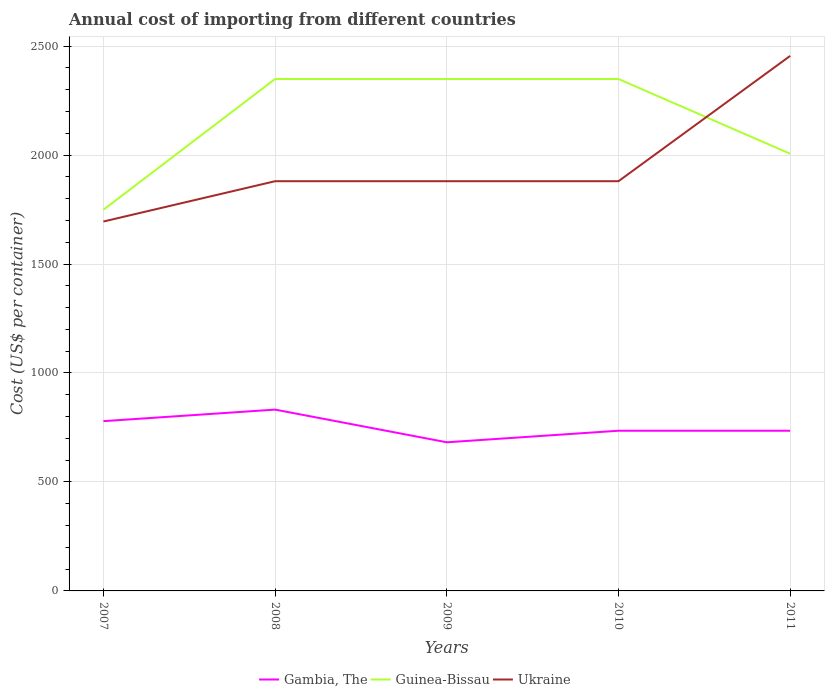How many different coloured lines are there?
Your answer should be very brief. 3. Is the number of lines equal to the number of legend labels?
Offer a very short reply. Yes. Across all years, what is the maximum total annual cost of importing in Ukraine?
Keep it short and to the point. 1695. In which year was the total annual cost of importing in Gambia, The maximum?
Ensure brevity in your answer.  2009. What is the total total annual cost of importing in Gambia, The in the graph?
Make the answer very short. 97. What is the difference between the highest and the second highest total annual cost of importing in Ukraine?
Your answer should be very brief. 760. What is the difference between the highest and the lowest total annual cost of importing in Guinea-Bissau?
Provide a short and direct response. 3. What is the difference between two consecutive major ticks on the Y-axis?
Ensure brevity in your answer.  500. Does the graph contain any zero values?
Your response must be concise. No. Does the graph contain grids?
Keep it short and to the point. Yes. How are the legend labels stacked?
Give a very brief answer. Horizontal. What is the title of the graph?
Provide a short and direct response. Annual cost of importing from different countries. Does "New Caledonia" appear as one of the legend labels in the graph?
Your answer should be very brief. No. What is the label or title of the X-axis?
Offer a terse response. Years. What is the label or title of the Y-axis?
Offer a terse response. Cost (US$ per container). What is the Cost (US$ per container) in Gambia, The in 2007?
Provide a short and direct response. 779. What is the Cost (US$ per container) in Guinea-Bissau in 2007?
Your answer should be very brief. 1749. What is the Cost (US$ per container) of Ukraine in 2007?
Offer a very short reply. 1695. What is the Cost (US$ per container) of Gambia, The in 2008?
Offer a very short reply. 832. What is the Cost (US$ per container) of Guinea-Bissau in 2008?
Make the answer very short. 2349. What is the Cost (US$ per container) in Ukraine in 2008?
Give a very brief answer. 1880. What is the Cost (US$ per container) of Gambia, The in 2009?
Your answer should be very brief. 682. What is the Cost (US$ per container) in Guinea-Bissau in 2009?
Offer a terse response. 2349. What is the Cost (US$ per container) of Ukraine in 2009?
Your answer should be very brief. 1880. What is the Cost (US$ per container) of Gambia, The in 2010?
Your answer should be compact. 735. What is the Cost (US$ per container) in Guinea-Bissau in 2010?
Ensure brevity in your answer.  2349. What is the Cost (US$ per container) in Ukraine in 2010?
Offer a terse response. 1880. What is the Cost (US$ per container) of Gambia, The in 2011?
Ensure brevity in your answer.  735. What is the Cost (US$ per container) in Guinea-Bissau in 2011?
Provide a succinct answer. 2006. What is the Cost (US$ per container) in Ukraine in 2011?
Your answer should be very brief. 2455. Across all years, what is the maximum Cost (US$ per container) in Gambia, The?
Provide a succinct answer. 832. Across all years, what is the maximum Cost (US$ per container) in Guinea-Bissau?
Your answer should be compact. 2349. Across all years, what is the maximum Cost (US$ per container) in Ukraine?
Your answer should be compact. 2455. Across all years, what is the minimum Cost (US$ per container) in Gambia, The?
Give a very brief answer. 682. Across all years, what is the minimum Cost (US$ per container) in Guinea-Bissau?
Give a very brief answer. 1749. Across all years, what is the minimum Cost (US$ per container) of Ukraine?
Ensure brevity in your answer.  1695. What is the total Cost (US$ per container) in Gambia, The in the graph?
Offer a terse response. 3763. What is the total Cost (US$ per container) of Guinea-Bissau in the graph?
Ensure brevity in your answer.  1.08e+04. What is the total Cost (US$ per container) of Ukraine in the graph?
Provide a succinct answer. 9790. What is the difference between the Cost (US$ per container) in Gambia, The in 2007 and that in 2008?
Your answer should be very brief. -53. What is the difference between the Cost (US$ per container) in Guinea-Bissau in 2007 and that in 2008?
Provide a short and direct response. -600. What is the difference between the Cost (US$ per container) in Ukraine in 2007 and that in 2008?
Offer a terse response. -185. What is the difference between the Cost (US$ per container) in Gambia, The in 2007 and that in 2009?
Provide a short and direct response. 97. What is the difference between the Cost (US$ per container) of Guinea-Bissau in 2007 and that in 2009?
Your response must be concise. -600. What is the difference between the Cost (US$ per container) in Ukraine in 2007 and that in 2009?
Provide a succinct answer. -185. What is the difference between the Cost (US$ per container) of Guinea-Bissau in 2007 and that in 2010?
Make the answer very short. -600. What is the difference between the Cost (US$ per container) in Ukraine in 2007 and that in 2010?
Provide a short and direct response. -185. What is the difference between the Cost (US$ per container) in Gambia, The in 2007 and that in 2011?
Your answer should be compact. 44. What is the difference between the Cost (US$ per container) in Guinea-Bissau in 2007 and that in 2011?
Ensure brevity in your answer.  -257. What is the difference between the Cost (US$ per container) in Ukraine in 2007 and that in 2011?
Your answer should be compact. -760. What is the difference between the Cost (US$ per container) in Gambia, The in 2008 and that in 2009?
Give a very brief answer. 150. What is the difference between the Cost (US$ per container) of Guinea-Bissau in 2008 and that in 2009?
Provide a short and direct response. 0. What is the difference between the Cost (US$ per container) of Ukraine in 2008 and that in 2009?
Your response must be concise. 0. What is the difference between the Cost (US$ per container) of Gambia, The in 2008 and that in 2010?
Provide a succinct answer. 97. What is the difference between the Cost (US$ per container) in Guinea-Bissau in 2008 and that in 2010?
Provide a succinct answer. 0. What is the difference between the Cost (US$ per container) of Ukraine in 2008 and that in 2010?
Your response must be concise. 0. What is the difference between the Cost (US$ per container) of Gambia, The in 2008 and that in 2011?
Offer a terse response. 97. What is the difference between the Cost (US$ per container) of Guinea-Bissau in 2008 and that in 2011?
Provide a succinct answer. 343. What is the difference between the Cost (US$ per container) of Ukraine in 2008 and that in 2011?
Provide a short and direct response. -575. What is the difference between the Cost (US$ per container) in Gambia, The in 2009 and that in 2010?
Ensure brevity in your answer.  -53. What is the difference between the Cost (US$ per container) in Ukraine in 2009 and that in 2010?
Offer a terse response. 0. What is the difference between the Cost (US$ per container) in Gambia, The in 2009 and that in 2011?
Provide a short and direct response. -53. What is the difference between the Cost (US$ per container) of Guinea-Bissau in 2009 and that in 2011?
Keep it short and to the point. 343. What is the difference between the Cost (US$ per container) of Ukraine in 2009 and that in 2011?
Provide a short and direct response. -575. What is the difference between the Cost (US$ per container) in Guinea-Bissau in 2010 and that in 2011?
Your answer should be very brief. 343. What is the difference between the Cost (US$ per container) of Ukraine in 2010 and that in 2011?
Provide a short and direct response. -575. What is the difference between the Cost (US$ per container) in Gambia, The in 2007 and the Cost (US$ per container) in Guinea-Bissau in 2008?
Give a very brief answer. -1570. What is the difference between the Cost (US$ per container) in Gambia, The in 2007 and the Cost (US$ per container) in Ukraine in 2008?
Provide a succinct answer. -1101. What is the difference between the Cost (US$ per container) in Guinea-Bissau in 2007 and the Cost (US$ per container) in Ukraine in 2008?
Provide a short and direct response. -131. What is the difference between the Cost (US$ per container) in Gambia, The in 2007 and the Cost (US$ per container) in Guinea-Bissau in 2009?
Give a very brief answer. -1570. What is the difference between the Cost (US$ per container) of Gambia, The in 2007 and the Cost (US$ per container) of Ukraine in 2009?
Your answer should be compact. -1101. What is the difference between the Cost (US$ per container) of Guinea-Bissau in 2007 and the Cost (US$ per container) of Ukraine in 2009?
Your response must be concise. -131. What is the difference between the Cost (US$ per container) of Gambia, The in 2007 and the Cost (US$ per container) of Guinea-Bissau in 2010?
Your response must be concise. -1570. What is the difference between the Cost (US$ per container) of Gambia, The in 2007 and the Cost (US$ per container) of Ukraine in 2010?
Your response must be concise. -1101. What is the difference between the Cost (US$ per container) of Guinea-Bissau in 2007 and the Cost (US$ per container) of Ukraine in 2010?
Ensure brevity in your answer.  -131. What is the difference between the Cost (US$ per container) of Gambia, The in 2007 and the Cost (US$ per container) of Guinea-Bissau in 2011?
Your answer should be compact. -1227. What is the difference between the Cost (US$ per container) of Gambia, The in 2007 and the Cost (US$ per container) of Ukraine in 2011?
Your response must be concise. -1676. What is the difference between the Cost (US$ per container) in Guinea-Bissau in 2007 and the Cost (US$ per container) in Ukraine in 2011?
Your answer should be compact. -706. What is the difference between the Cost (US$ per container) in Gambia, The in 2008 and the Cost (US$ per container) in Guinea-Bissau in 2009?
Provide a succinct answer. -1517. What is the difference between the Cost (US$ per container) of Gambia, The in 2008 and the Cost (US$ per container) of Ukraine in 2009?
Provide a short and direct response. -1048. What is the difference between the Cost (US$ per container) in Guinea-Bissau in 2008 and the Cost (US$ per container) in Ukraine in 2009?
Keep it short and to the point. 469. What is the difference between the Cost (US$ per container) of Gambia, The in 2008 and the Cost (US$ per container) of Guinea-Bissau in 2010?
Ensure brevity in your answer.  -1517. What is the difference between the Cost (US$ per container) in Gambia, The in 2008 and the Cost (US$ per container) in Ukraine in 2010?
Offer a terse response. -1048. What is the difference between the Cost (US$ per container) in Guinea-Bissau in 2008 and the Cost (US$ per container) in Ukraine in 2010?
Offer a terse response. 469. What is the difference between the Cost (US$ per container) of Gambia, The in 2008 and the Cost (US$ per container) of Guinea-Bissau in 2011?
Provide a succinct answer. -1174. What is the difference between the Cost (US$ per container) of Gambia, The in 2008 and the Cost (US$ per container) of Ukraine in 2011?
Ensure brevity in your answer.  -1623. What is the difference between the Cost (US$ per container) in Guinea-Bissau in 2008 and the Cost (US$ per container) in Ukraine in 2011?
Your answer should be very brief. -106. What is the difference between the Cost (US$ per container) of Gambia, The in 2009 and the Cost (US$ per container) of Guinea-Bissau in 2010?
Give a very brief answer. -1667. What is the difference between the Cost (US$ per container) of Gambia, The in 2009 and the Cost (US$ per container) of Ukraine in 2010?
Your response must be concise. -1198. What is the difference between the Cost (US$ per container) of Guinea-Bissau in 2009 and the Cost (US$ per container) of Ukraine in 2010?
Your answer should be very brief. 469. What is the difference between the Cost (US$ per container) of Gambia, The in 2009 and the Cost (US$ per container) of Guinea-Bissau in 2011?
Offer a terse response. -1324. What is the difference between the Cost (US$ per container) of Gambia, The in 2009 and the Cost (US$ per container) of Ukraine in 2011?
Provide a short and direct response. -1773. What is the difference between the Cost (US$ per container) in Guinea-Bissau in 2009 and the Cost (US$ per container) in Ukraine in 2011?
Your answer should be compact. -106. What is the difference between the Cost (US$ per container) of Gambia, The in 2010 and the Cost (US$ per container) of Guinea-Bissau in 2011?
Offer a terse response. -1271. What is the difference between the Cost (US$ per container) of Gambia, The in 2010 and the Cost (US$ per container) of Ukraine in 2011?
Offer a very short reply. -1720. What is the difference between the Cost (US$ per container) of Guinea-Bissau in 2010 and the Cost (US$ per container) of Ukraine in 2011?
Your response must be concise. -106. What is the average Cost (US$ per container) of Gambia, The per year?
Give a very brief answer. 752.6. What is the average Cost (US$ per container) in Guinea-Bissau per year?
Offer a very short reply. 2160.4. What is the average Cost (US$ per container) in Ukraine per year?
Offer a very short reply. 1958. In the year 2007, what is the difference between the Cost (US$ per container) of Gambia, The and Cost (US$ per container) of Guinea-Bissau?
Your answer should be very brief. -970. In the year 2007, what is the difference between the Cost (US$ per container) in Gambia, The and Cost (US$ per container) in Ukraine?
Give a very brief answer. -916. In the year 2007, what is the difference between the Cost (US$ per container) in Guinea-Bissau and Cost (US$ per container) in Ukraine?
Make the answer very short. 54. In the year 2008, what is the difference between the Cost (US$ per container) in Gambia, The and Cost (US$ per container) in Guinea-Bissau?
Keep it short and to the point. -1517. In the year 2008, what is the difference between the Cost (US$ per container) in Gambia, The and Cost (US$ per container) in Ukraine?
Provide a succinct answer. -1048. In the year 2008, what is the difference between the Cost (US$ per container) of Guinea-Bissau and Cost (US$ per container) of Ukraine?
Provide a succinct answer. 469. In the year 2009, what is the difference between the Cost (US$ per container) of Gambia, The and Cost (US$ per container) of Guinea-Bissau?
Your answer should be very brief. -1667. In the year 2009, what is the difference between the Cost (US$ per container) of Gambia, The and Cost (US$ per container) of Ukraine?
Your answer should be compact. -1198. In the year 2009, what is the difference between the Cost (US$ per container) of Guinea-Bissau and Cost (US$ per container) of Ukraine?
Provide a short and direct response. 469. In the year 2010, what is the difference between the Cost (US$ per container) in Gambia, The and Cost (US$ per container) in Guinea-Bissau?
Offer a terse response. -1614. In the year 2010, what is the difference between the Cost (US$ per container) of Gambia, The and Cost (US$ per container) of Ukraine?
Your answer should be very brief. -1145. In the year 2010, what is the difference between the Cost (US$ per container) in Guinea-Bissau and Cost (US$ per container) in Ukraine?
Ensure brevity in your answer.  469. In the year 2011, what is the difference between the Cost (US$ per container) of Gambia, The and Cost (US$ per container) of Guinea-Bissau?
Offer a very short reply. -1271. In the year 2011, what is the difference between the Cost (US$ per container) in Gambia, The and Cost (US$ per container) in Ukraine?
Ensure brevity in your answer.  -1720. In the year 2011, what is the difference between the Cost (US$ per container) in Guinea-Bissau and Cost (US$ per container) in Ukraine?
Provide a short and direct response. -449. What is the ratio of the Cost (US$ per container) of Gambia, The in 2007 to that in 2008?
Keep it short and to the point. 0.94. What is the ratio of the Cost (US$ per container) of Guinea-Bissau in 2007 to that in 2008?
Provide a succinct answer. 0.74. What is the ratio of the Cost (US$ per container) in Ukraine in 2007 to that in 2008?
Make the answer very short. 0.9. What is the ratio of the Cost (US$ per container) in Gambia, The in 2007 to that in 2009?
Give a very brief answer. 1.14. What is the ratio of the Cost (US$ per container) of Guinea-Bissau in 2007 to that in 2009?
Your answer should be very brief. 0.74. What is the ratio of the Cost (US$ per container) of Ukraine in 2007 to that in 2009?
Provide a succinct answer. 0.9. What is the ratio of the Cost (US$ per container) of Gambia, The in 2007 to that in 2010?
Your response must be concise. 1.06. What is the ratio of the Cost (US$ per container) of Guinea-Bissau in 2007 to that in 2010?
Your response must be concise. 0.74. What is the ratio of the Cost (US$ per container) of Ukraine in 2007 to that in 2010?
Ensure brevity in your answer.  0.9. What is the ratio of the Cost (US$ per container) of Gambia, The in 2007 to that in 2011?
Provide a short and direct response. 1.06. What is the ratio of the Cost (US$ per container) of Guinea-Bissau in 2007 to that in 2011?
Provide a succinct answer. 0.87. What is the ratio of the Cost (US$ per container) of Ukraine in 2007 to that in 2011?
Your answer should be compact. 0.69. What is the ratio of the Cost (US$ per container) in Gambia, The in 2008 to that in 2009?
Your response must be concise. 1.22. What is the ratio of the Cost (US$ per container) in Guinea-Bissau in 2008 to that in 2009?
Provide a succinct answer. 1. What is the ratio of the Cost (US$ per container) of Gambia, The in 2008 to that in 2010?
Provide a succinct answer. 1.13. What is the ratio of the Cost (US$ per container) in Guinea-Bissau in 2008 to that in 2010?
Offer a terse response. 1. What is the ratio of the Cost (US$ per container) in Ukraine in 2008 to that in 2010?
Provide a short and direct response. 1. What is the ratio of the Cost (US$ per container) in Gambia, The in 2008 to that in 2011?
Ensure brevity in your answer.  1.13. What is the ratio of the Cost (US$ per container) in Guinea-Bissau in 2008 to that in 2011?
Your answer should be compact. 1.17. What is the ratio of the Cost (US$ per container) of Ukraine in 2008 to that in 2011?
Keep it short and to the point. 0.77. What is the ratio of the Cost (US$ per container) of Gambia, The in 2009 to that in 2010?
Make the answer very short. 0.93. What is the ratio of the Cost (US$ per container) of Ukraine in 2009 to that in 2010?
Offer a very short reply. 1. What is the ratio of the Cost (US$ per container) in Gambia, The in 2009 to that in 2011?
Ensure brevity in your answer.  0.93. What is the ratio of the Cost (US$ per container) in Guinea-Bissau in 2009 to that in 2011?
Your answer should be compact. 1.17. What is the ratio of the Cost (US$ per container) of Ukraine in 2009 to that in 2011?
Provide a short and direct response. 0.77. What is the ratio of the Cost (US$ per container) of Guinea-Bissau in 2010 to that in 2011?
Offer a terse response. 1.17. What is the ratio of the Cost (US$ per container) in Ukraine in 2010 to that in 2011?
Offer a terse response. 0.77. What is the difference between the highest and the second highest Cost (US$ per container) in Guinea-Bissau?
Offer a terse response. 0. What is the difference between the highest and the second highest Cost (US$ per container) of Ukraine?
Your response must be concise. 575. What is the difference between the highest and the lowest Cost (US$ per container) in Gambia, The?
Make the answer very short. 150. What is the difference between the highest and the lowest Cost (US$ per container) in Guinea-Bissau?
Ensure brevity in your answer.  600. What is the difference between the highest and the lowest Cost (US$ per container) in Ukraine?
Your response must be concise. 760. 